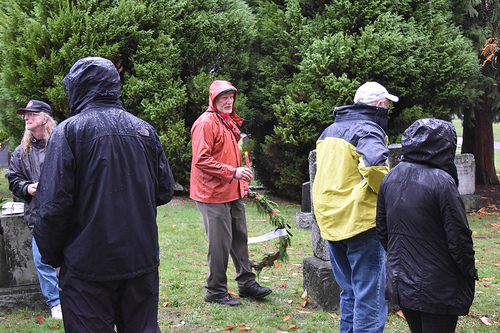<image>
Can you confirm if the man is behind the plant? No. The man is not behind the plant. From this viewpoint, the man appears to be positioned elsewhere in the scene. Is the man next to the man? Yes. The man is positioned adjacent to the man, located nearby in the same general area. 